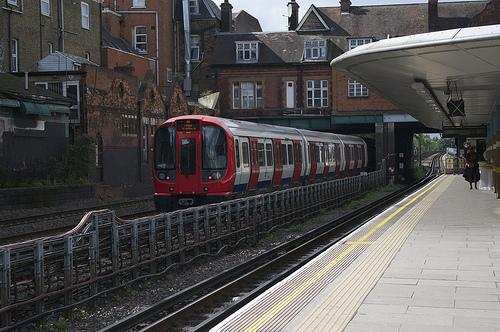What is the color of the train in the image and which part of it stands out? The train is red, white, and blue, with a red headlight standing out. Describe a particular detail of the boarding platform. The boarding platform has an overhang providing shelter for the waiting passengers. Identify the primary focus of the image and mention the action occurring in it. A red metro train arrives at a station with passengers waiting on the platform, surrounded by multi-story buildings, and multiple objects like warning lines, guard rails, and windows. Mention a unique feature of the buildings around the train tracks. The stone and brick buildings have numerous windows on their sides, contributing to their uniqueness. How many passengers can be seen waiting on the platform in the image? There is one person waiting for the train on the platform. Provide a brief summary of the scene captured in the image. The scene showcases a red, white, and blue metro train arriving at a station, with passengers waiting on the platform, stone and brick buildings nearby, and various objects such as guard rails, warning lines, and windows. Mention an object found adjacent to the train tracks and describe its charactersitics. The yellow warning line nearby the tracks is a prominent feature, defining the safe distance for passengers waiting on the platform. What are the windows on the side of the train like? There are multiple windows on the train's side, varying in size with the smallest measuring 4 units and the largest measuring 20 units in height and width. What specific aspect of the train's exterior is noteworthy? The red headlight on the train is prominent and distinguishes it from its surroundings. Can you find any indication of safety measures present in the image? Yes, there is a yellow warning line by the train tracks, signaling passengers where to stand for safety. 